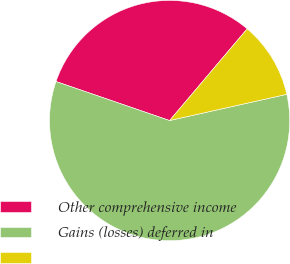Convert chart. <chart><loc_0><loc_0><loc_500><loc_500><pie_chart><fcel>Other comprehensive income<fcel>Gains (losses) deferred in<fcel>Unnamed: 2<nl><fcel>30.91%<fcel>58.77%<fcel>10.32%<nl></chart> 